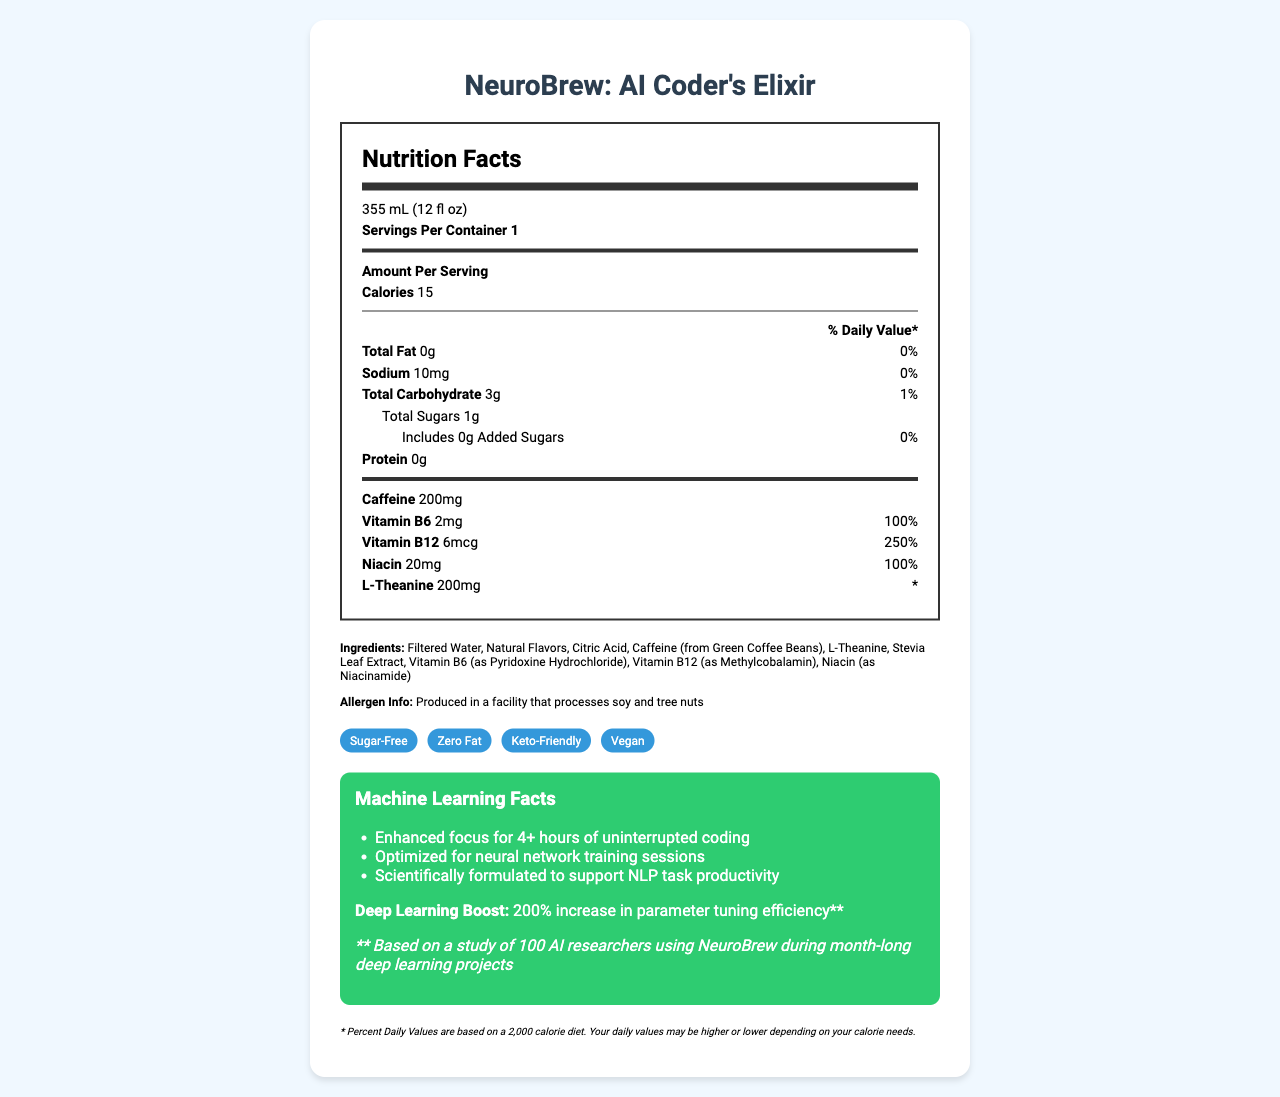how many servings per container are there? The document clearly states there is 1 serving per container.
Answer: 1 what is the serving size of NeuroBrew? According to the document, the serving size is specified as 355 mL (12 fl oz).
Answer: 355 mL (12 fl oz) how many calories are in one serving of NeuroBrew? The document mentions that one serving contains 15 calories.
Answer: 15 what is the sodium content in NeuroBrew? The sodium content is listed as 10mg per serving.
Answer: 10mg name two vitamins included in NeuroBrew and their respective amounts. The document specifies Vitamin B6 as 2mg and Vitamin B12 as 6mcg.
Answer: Vitamin B6 (2mg) and Vitamin B12 (6mcg) which of the following is not an ingredient in NeuroBrew? A. Stevia Leaf Extract B. Aspartame C. Citric Acid D. Filtered Water Aspartame is not listed as an ingredient in NeuroBrew.
Answer: B what claims does NeuroBrew make about its product? A. Sugar-Free B. Contains High Protein C. Zero Fat D. Keto-Friendly The claims listed include "Sugar-Free," "Zero Fat," and "Keto-Friendly." "Contains High Protein" is not listed.
Answer: A, C, D is NeuroBrew vegan? The document explicitly states that NeuroBrew is vegan.
Answer: Yes describe the potential productivity benefits of drinking NeuroBrew according to the document. The document outlines these specific benefits associated with the beverage.
Answer: NeuroBrew is said to enhance focus for 4+ hours of uninterrupted coding, optimize neural network training sessions, and support NLP task productivity, with a claimed 200% increase in parameter tuning efficiency based on a study of 100 AI researchers. what is the caffeine content per serving in NeuroBrew? The caffeine content is specified as 200mg per serving.
Answer: 200mg is NeuroBrew suitable for someone following a keto diet? The document states that NeuroBrew is keto-friendly.
Answer: Yes does NeuroBrew contain any added sugars? The document indicates that NeuroBrew includes 0g of added sugars.
Answer: No how is the daily value percentage for a nutrient determined according to the disclaimer? The disclaimer in the document says that the Percent Daily Values are based on a 2,000 calorie diet.
Answer: Based on a 2,000 calorie diet what is the major allergen information provided about NeuroBrew? The allergen info section specifies this detail.
Answer: Produced in a facility that processes soy and tree nuts how much protein does NeuroBrew contain per serving? The protein content is indicated as 0g per serving.
Answer: 0g does the document provide the production or expiry date of NeuroBrew? The document does not mention the production or expiry date details.
Answer: Not enough information 